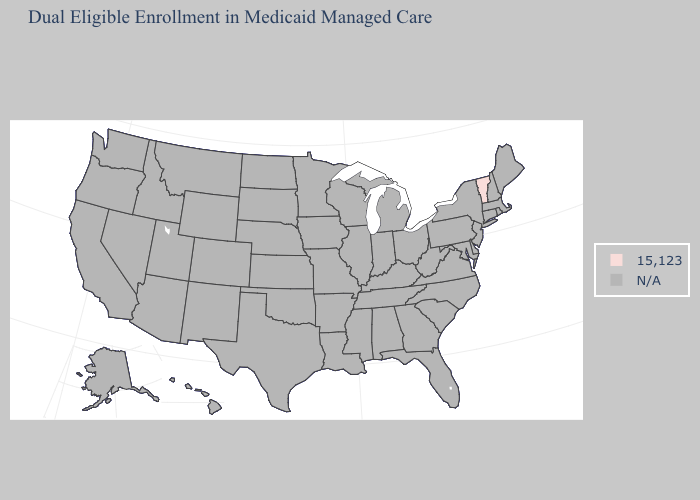Name the states that have a value in the range N/A?
Keep it brief. Alabama, Alaska, Arizona, Arkansas, California, Colorado, Connecticut, Delaware, Florida, Georgia, Hawaii, Idaho, Illinois, Indiana, Iowa, Kansas, Kentucky, Louisiana, Maine, Maryland, Massachusetts, Michigan, Minnesota, Mississippi, Missouri, Montana, Nebraska, Nevada, New Hampshire, New Jersey, New Mexico, New York, North Carolina, North Dakota, Ohio, Oklahoma, Oregon, Pennsylvania, Rhode Island, South Carolina, South Dakota, Tennessee, Texas, Utah, Virginia, Washington, West Virginia, Wisconsin, Wyoming. What is the value of North Carolina?
Answer briefly. N/A. Name the states that have a value in the range 15,123?
Be succinct. Vermont. Name the states that have a value in the range N/A?
Be succinct. Alabama, Alaska, Arizona, Arkansas, California, Colorado, Connecticut, Delaware, Florida, Georgia, Hawaii, Idaho, Illinois, Indiana, Iowa, Kansas, Kentucky, Louisiana, Maine, Maryland, Massachusetts, Michigan, Minnesota, Mississippi, Missouri, Montana, Nebraska, Nevada, New Hampshire, New Jersey, New Mexico, New York, North Carolina, North Dakota, Ohio, Oklahoma, Oregon, Pennsylvania, Rhode Island, South Carolina, South Dakota, Tennessee, Texas, Utah, Virginia, Washington, West Virginia, Wisconsin, Wyoming. What is the value of Texas?
Answer briefly. N/A. Name the states that have a value in the range N/A?
Be succinct. Alabama, Alaska, Arizona, Arkansas, California, Colorado, Connecticut, Delaware, Florida, Georgia, Hawaii, Idaho, Illinois, Indiana, Iowa, Kansas, Kentucky, Louisiana, Maine, Maryland, Massachusetts, Michigan, Minnesota, Mississippi, Missouri, Montana, Nebraska, Nevada, New Hampshire, New Jersey, New Mexico, New York, North Carolina, North Dakota, Ohio, Oklahoma, Oregon, Pennsylvania, Rhode Island, South Carolina, South Dakota, Tennessee, Texas, Utah, Virginia, Washington, West Virginia, Wisconsin, Wyoming. How many symbols are there in the legend?
Keep it brief. 2. 